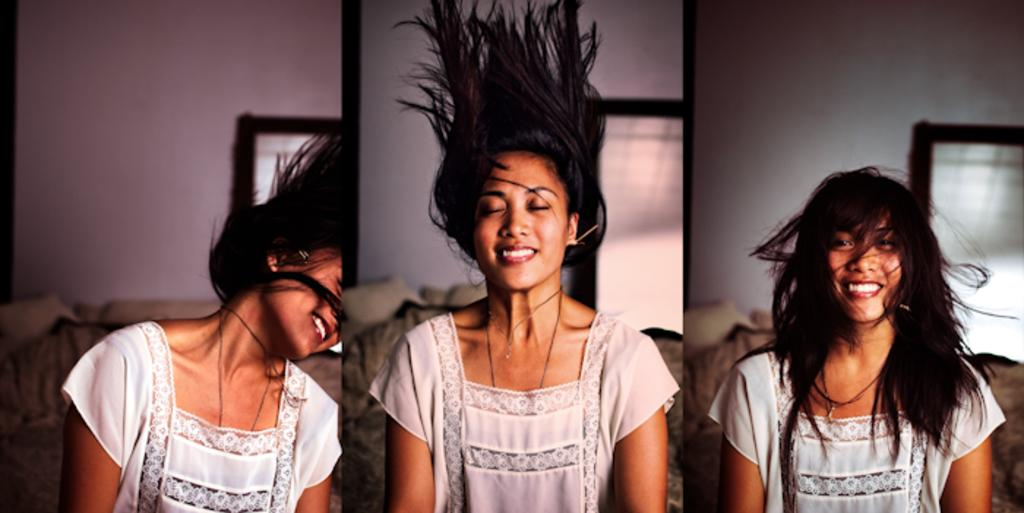What is the gender of the person in the image? The person in the image is a lady. What is the lady wearing in the image? The lady is wearing a white dress. What can be seen in the background of the image? There is a couch, a wall, and a window in the background of the image. What type of corn can be seen growing on the farm in the image? There is no corn or farm present in the image; it features a lady wearing a white dress with a background of a couch, wall, and window. What brand of soap is the lady using in the image? There is no soap or indication of soap use in the image. 